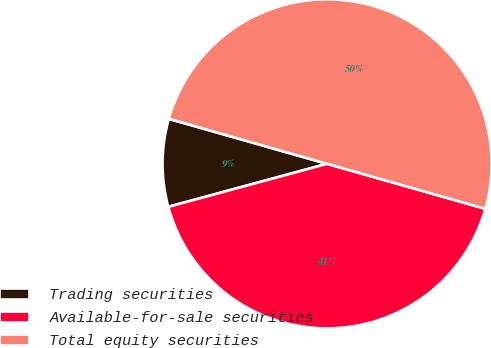Convert chart. <chart><loc_0><loc_0><loc_500><loc_500><pie_chart><fcel>Trading securities<fcel>Available-for-sale securities<fcel>Total equity securities<nl><fcel>8.62%<fcel>41.38%<fcel>50.0%<nl></chart> 